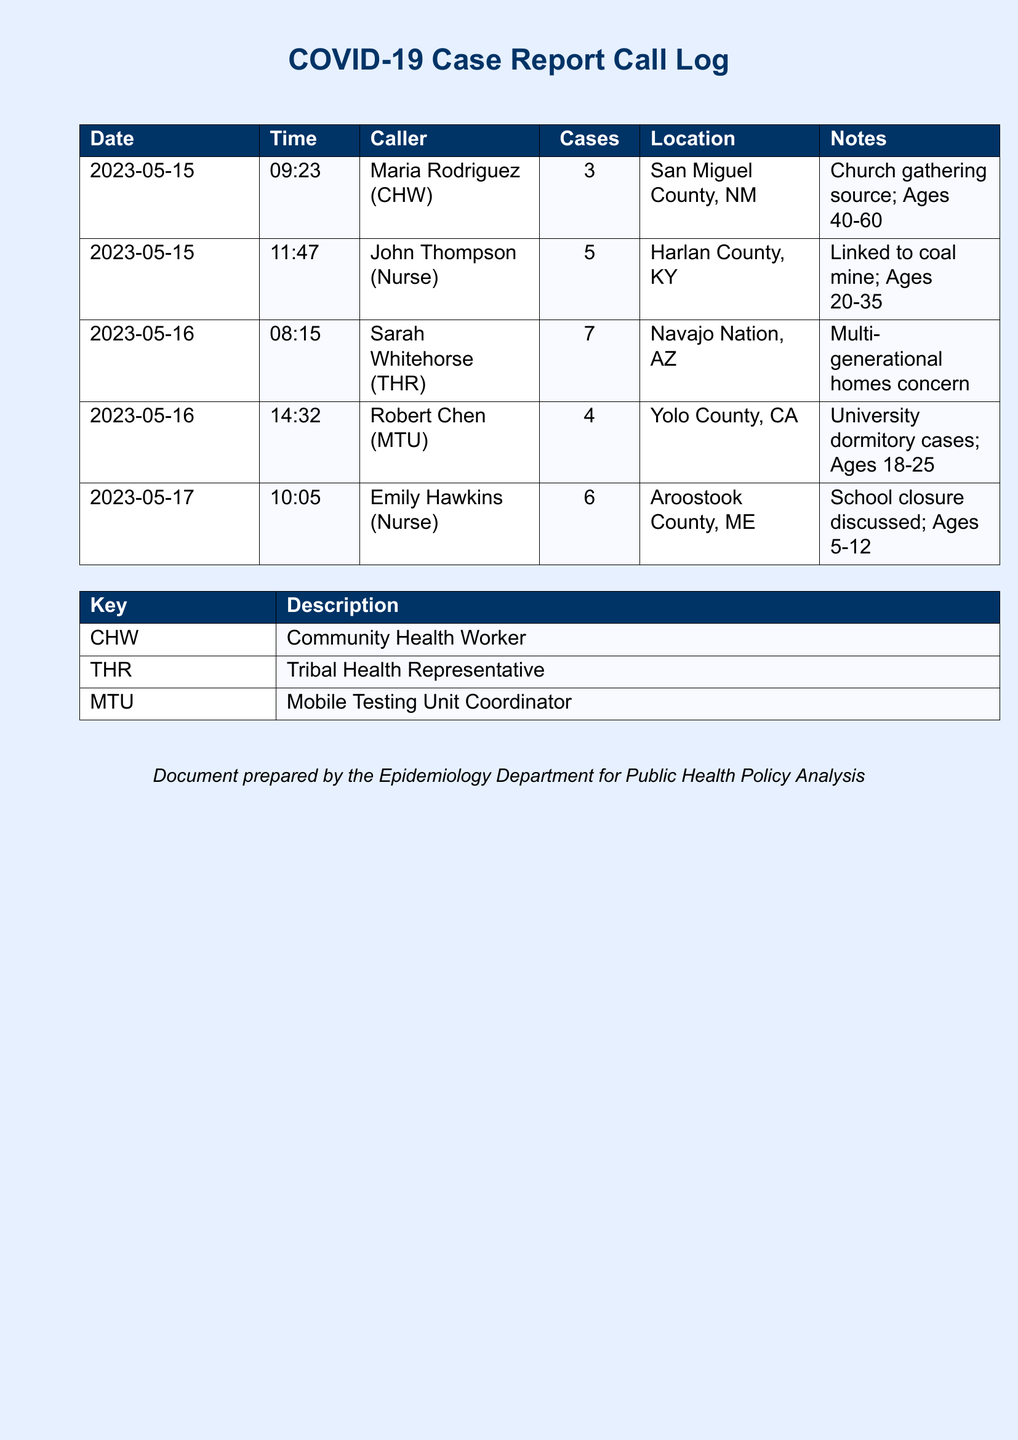What is the date of the first reported case? The first reported case in the document is from May 15, 2023.
Answer: May 15, 2023 How many cases were reported by Sarah Whitehorse? Sarah Whitehorse reported 7 cases.
Answer: 7 Which location had cases linked to a church gathering? The cases linked to a church gathering were reported from San Miguel County, NM.
Answer: San Miguel County, NM Who reported the highest number of cases? Sarah Whitehorse reported the highest number with 7 cases.
Answer: Sarah Whitehorse What is the age range of cases reported in Harlan County, KY? The age range of cases reported in Harlan County, KY is 20-35.
Answer: 20-35 What type of representative is Maria Rodriguez? Maria Rodriguez is identified as a Community Health Worker (CHW).
Answer: Community Health Worker What common concern was noted in cases from the Navajo Nation? The common concern noted was about multi-generational homes.
Answer: Multi-generational homes How many cases were reported in Aroostook County, ME? Aroostook County, ME had 6 cases reported.
Answer: 6 Who reported on the school closure discussion? Emily Hawkins reported on the school closure discussion.
Answer: Emily Hawkins 